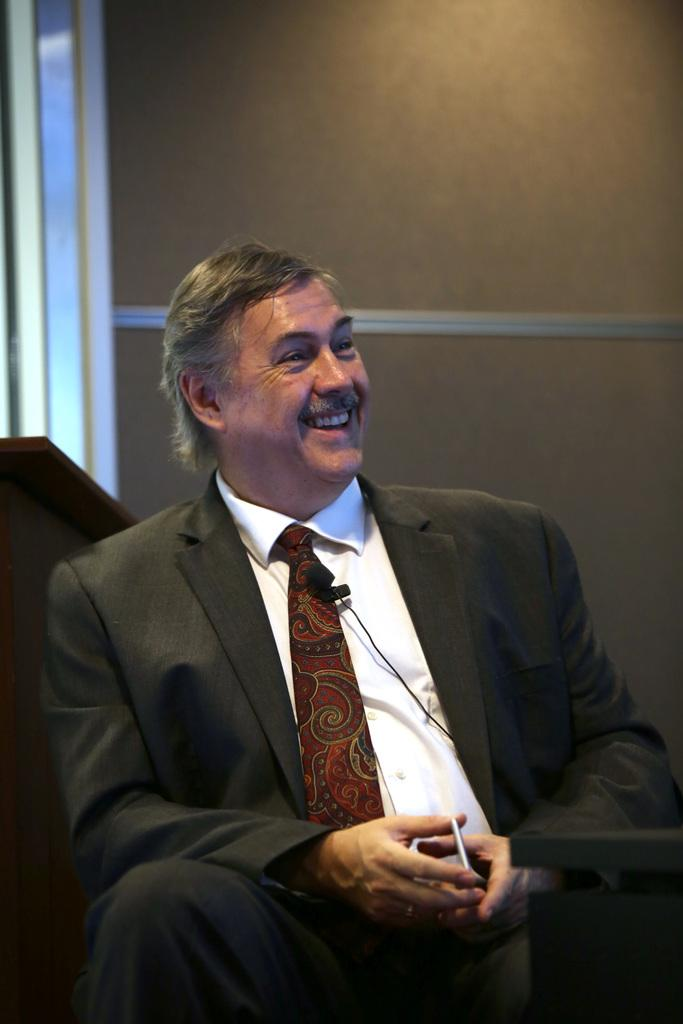What is the person in the image wearing? The person is wearing a blazer, a tie, and a white color shirt. What is the person holding in the image? The person is holding a mobile phone. What is the person's posture in the image? The person is sitting. What is the person's facial expression in the image? The person is smiling. What can be seen in the background of the image? There is a wall in the background of the image. How many books can be seen on the person's chin in the image? There are no books visible on the person's chin in the image. 